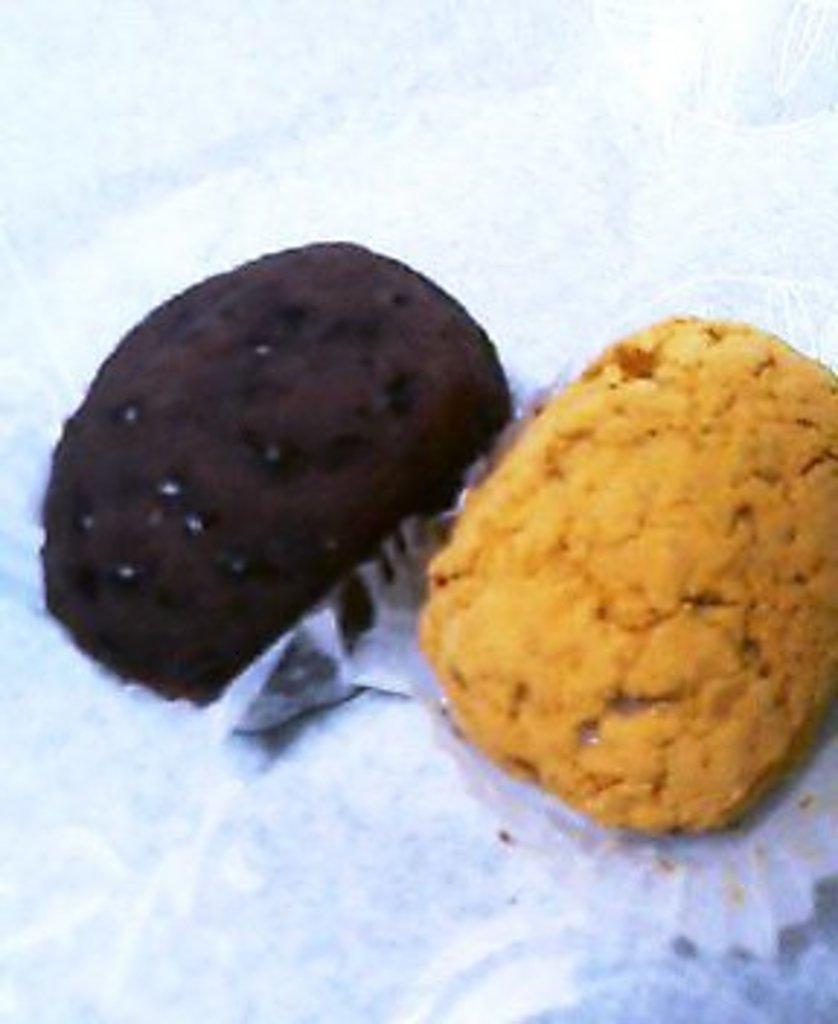Please provide a concise description of this image. Here we can see two cupcakes on a platform. 